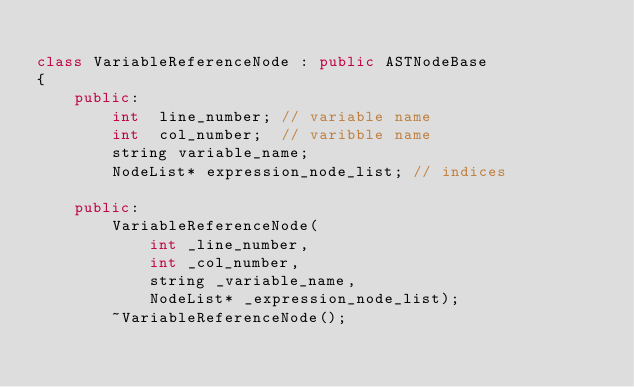<code> <loc_0><loc_0><loc_500><loc_500><_C++_>
class VariableReferenceNode : public ASTNodeBase
{
    public:
        int  line_number; // variable name
        int  col_number;  // varibble name
        string variable_name;
        NodeList* expression_node_list; // indices

    public:
        VariableReferenceNode(
            int _line_number, 
            int _col_number, 
            string _variable_name, 
            NodeList* _expression_node_list);
        ~VariableReferenceNode();</code> 